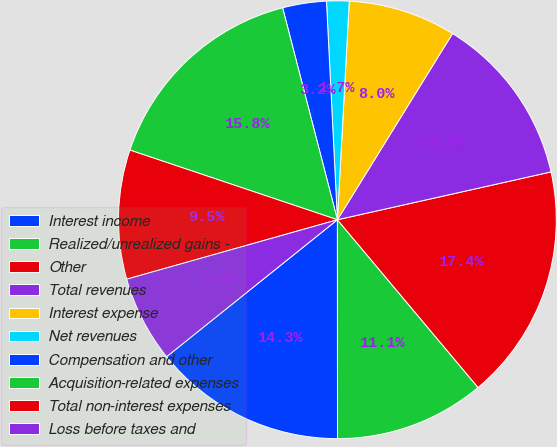Convert chart. <chart><loc_0><loc_0><loc_500><loc_500><pie_chart><fcel>Interest income<fcel>Realized/unrealized gains -<fcel>Other<fcel>Total revenues<fcel>Interest expense<fcel>Net revenues<fcel>Compensation and other<fcel>Acquisition-related expenses<fcel>Total non-interest expenses<fcel>Loss before taxes and<nl><fcel>14.25%<fcel>11.1%<fcel>17.4%<fcel>12.68%<fcel>7.95%<fcel>1.66%<fcel>3.23%<fcel>15.82%<fcel>9.53%<fcel>6.38%<nl></chart> 